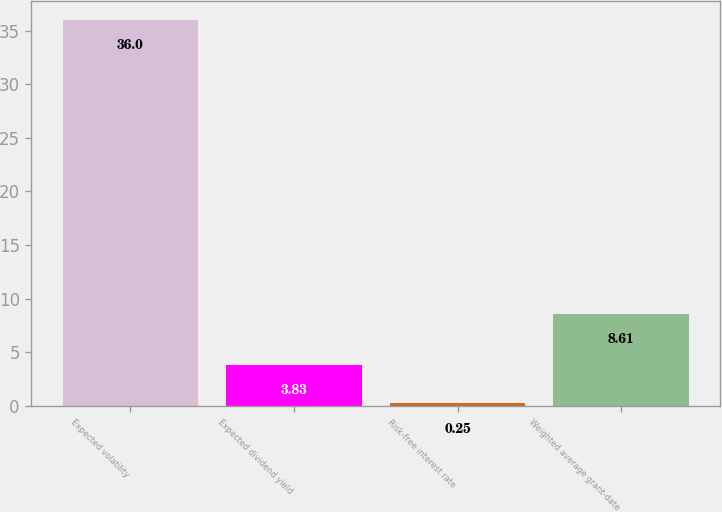Convert chart to OTSL. <chart><loc_0><loc_0><loc_500><loc_500><bar_chart><fcel>Expected volatility<fcel>Expected dividend yield<fcel>Risk-free interest rate<fcel>Weighted average grant-date<nl><fcel>36<fcel>3.83<fcel>0.25<fcel>8.61<nl></chart> 